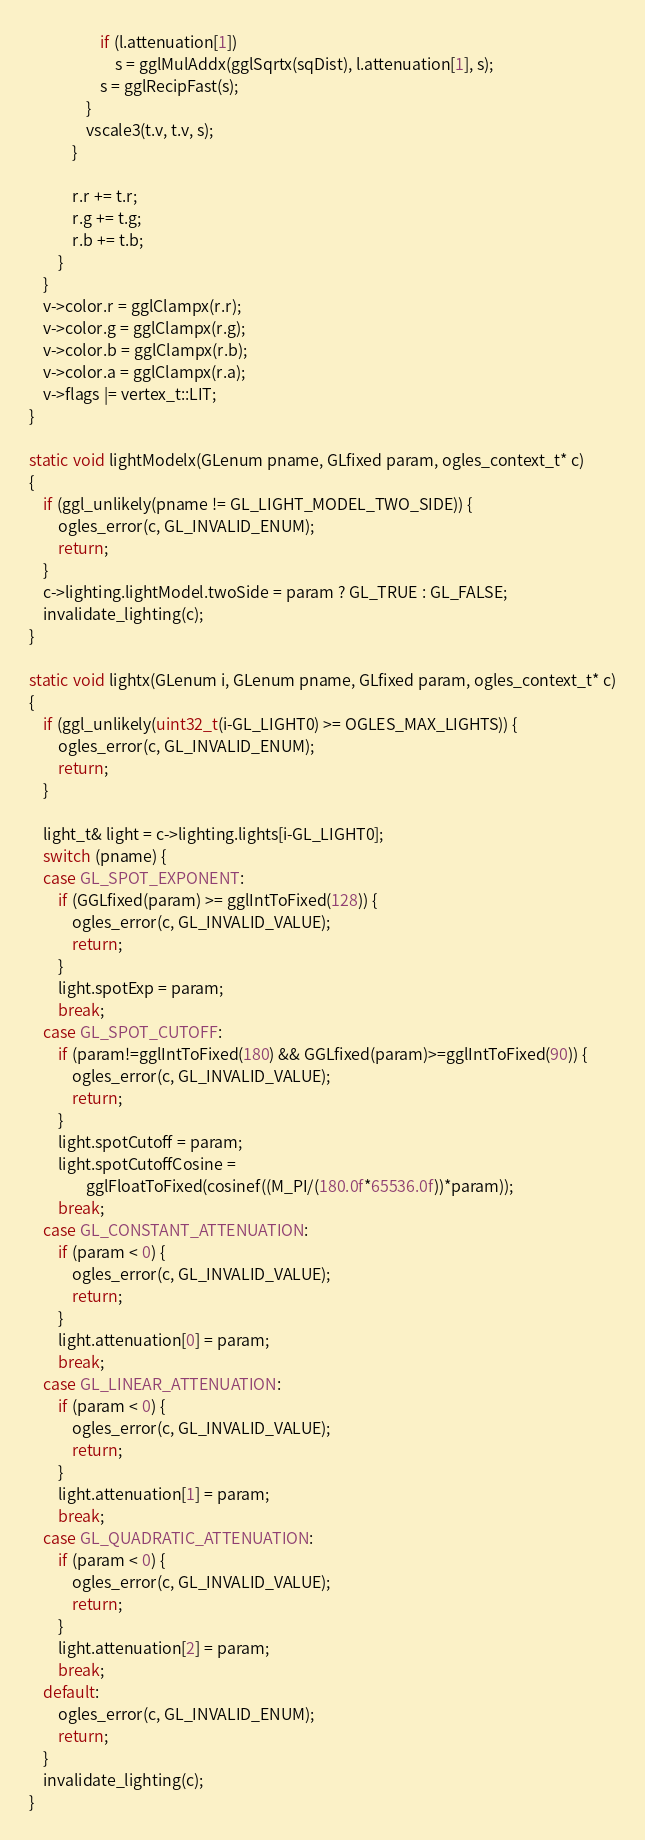<code> <loc_0><loc_0><loc_500><loc_500><_C++_>                    if (l.attenuation[1])
                        s = gglMulAddx(gglSqrtx(sqDist), l.attenuation[1], s);
                    s = gglRecipFast(s);
                }
                vscale3(t.v, t.v, s);
            }

            r.r += t.r;
            r.g += t.g;
            r.b += t.b;
        }
    }
    v->color.r = gglClampx(r.r);
    v->color.g = gglClampx(r.g);
    v->color.b = gglClampx(r.b);
    v->color.a = gglClampx(r.a);
    v->flags |= vertex_t::LIT;
}

static void lightModelx(GLenum pname, GLfixed param, ogles_context_t* c)
{
    if (ggl_unlikely(pname != GL_LIGHT_MODEL_TWO_SIDE)) {
        ogles_error(c, GL_INVALID_ENUM);
        return;
    }
    c->lighting.lightModel.twoSide = param ? GL_TRUE : GL_FALSE;
    invalidate_lighting(c);
}

static void lightx(GLenum i, GLenum pname, GLfixed param, ogles_context_t* c)
{
    if (ggl_unlikely(uint32_t(i-GL_LIGHT0) >= OGLES_MAX_LIGHTS)) {
        ogles_error(c, GL_INVALID_ENUM);
        return;
    }

    light_t& light = c->lighting.lights[i-GL_LIGHT0];
    switch (pname) {
    case GL_SPOT_EXPONENT:
        if (GGLfixed(param) >= gglIntToFixed(128)) {
            ogles_error(c, GL_INVALID_VALUE);
            return;
        }
        light.spotExp = param;
        break;
    case GL_SPOT_CUTOFF:
        if (param!=gglIntToFixed(180) && GGLfixed(param)>=gglIntToFixed(90)) {
            ogles_error(c, GL_INVALID_VALUE);
            return;
        }
        light.spotCutoff = param;
        light.spotCutoffCosine = 
                gglFloatToFixed(cosinef((M_PI/(180.0f*65536.0f))*param));
        break;
    case GL_CONSTANT_ATTENUATION:
        if (param < 0) {
            ogles_error(c, GL_INVALID_VALUE);
            return;
        }
        light.attenuation[0] = param;
        break;
    case GL_LINEAR_ATTENUATION:
        if (param < 0) {
            ogles_error(c, GL_INVALID_VALUE);
            return;
        }
        light.attenuation[1] = param;
        break;
    case GL_QUADRATIC_ATTENUATION:
        if (param < 0) {
            ogles_error(c, GL_INVALID_VALUE);
            return;
        }
        light.attenuation[2] = param;
        break;
    default:
        ogles_error(c, GL_INVALID_ENUM);
        return;
    }
    invalidate_lighting(c);
}
</code> 